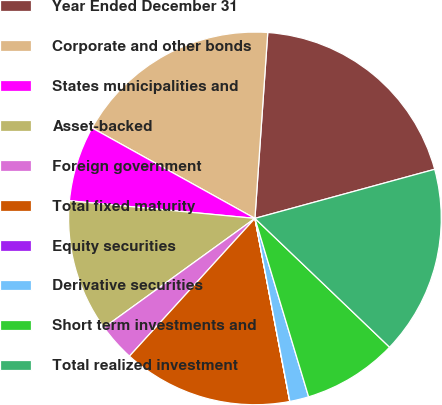<chart> <loc_0><loc_0><loc_500><loc_500><pie_chart><fcel>Year Ended December 31<fcel>Corporate and other bonds<fcel>States municipalities and<fcel>Asset-backed<fcel>Foreign government<fcel>Total fixed maturity<fcel>Equity securities<fcel>Derivative securities<fcel>Short term investments and<fcel>Total realized investment<nl><fcel>19.66%<fcel>18.03%<fcel>6.56%<fcel>11.47%<fcel>3.28%<fcel>14.75%<fcel>0.01%<fcel>1.65%<fcel>8.2%<fcel>16.39%<nl></chart> 